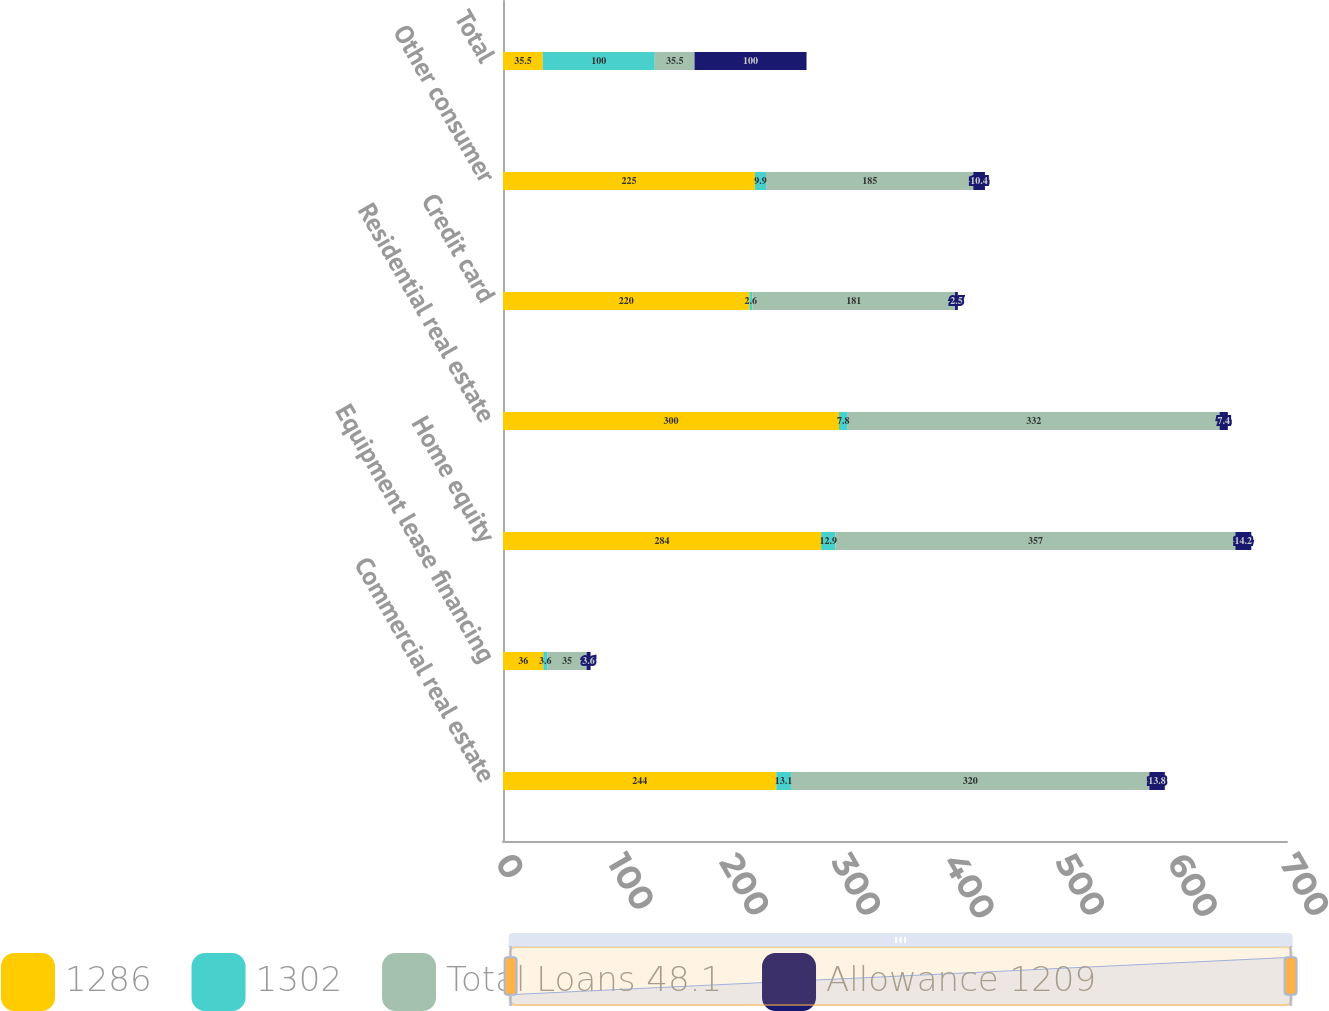<chart> <loc_0><loc_0><loc_500><loc_500><stacked_bar_chart><ecel><fcel>Commercial real estate<fcel>Equipment lease financing<fcel>Home equity<fcel>Residential real estate<fcel>Credit card<fcel>Other consumer<fcel>Total<nl><fcel>1286<fcel>244<fcel>36<fcel>284<fcel>300<fcel>220<fcel>225<fcel>35.5<nl><fcel>1302<fcel>13.1<fcel>3.6<fcel>12.9<fcel>7.8<fcel>2.6<fcel>9.9<fcel>100<nl><fcel>Total Loans 48.1<fcel>320<fcel>35<fcel>357<fcel>332<fcel>181<fcel>185<fcel>35.5<nl><fcel>Allowance 1209<fcel>13.8<fcel>3.6<fcel>14.2<fcel>7.4<fcel>2.5<fcel>10.4<fcel>100<nl></chart> 